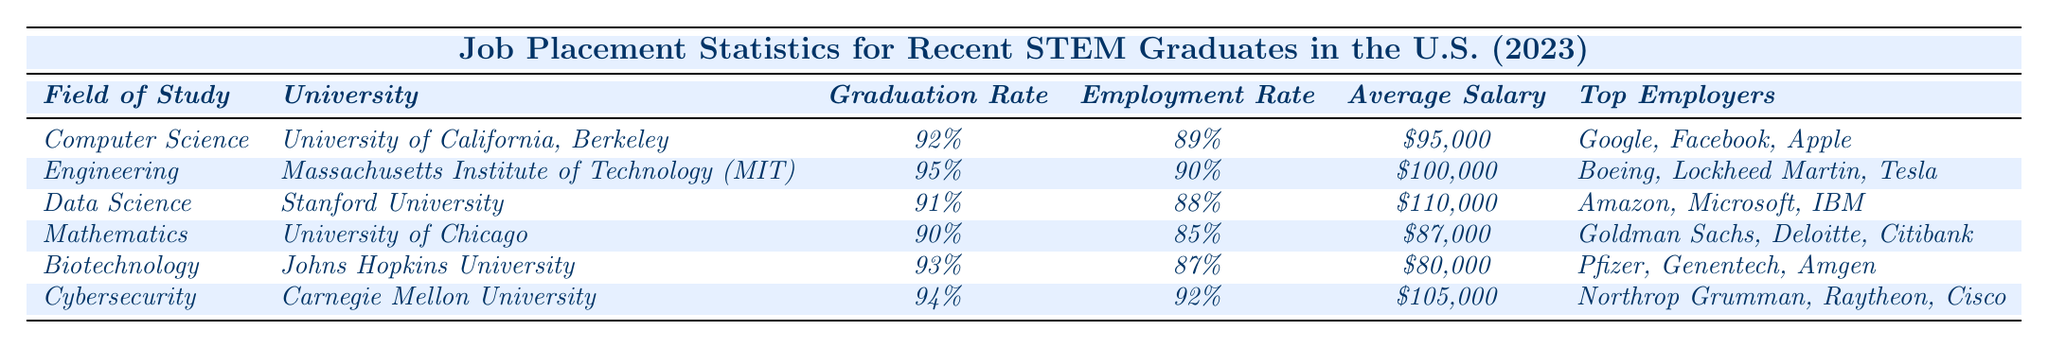What is the highest average salary among the fields of study listed? The average salaries for each field are $95,000 for Computer Science, $100,000 for Engineering, $110,000 for Data Science, $87,000 for Mathematics, $80,000 for Biotechnology, and $105,000 for Cybersecurity. The highest value is $110,000 for Data Science.
Answer: $110,000 Which university has the highest graduation rate? The graduation rates are 92% for Computer Science, 95% for Engineering, 91% for Data Science, 90% for Mathematics, 93% for Biotechnology, and 94% for Cybersecurity. The highest rate is 95% from MIT for Engineering.
Answer: 95% What percentage of graduates in Biotechnology found employment? The employment rate for Biotechnology graduates is 87%, as stated in the table.
Answer: 87% Is the average salary for graduates in Mathematics higher or lower than that for graduates in Computer Science? The average salary for Mathematics is $87,000, while for Computer Science it is $95,000. Since $87,000 is less than $95,000, it is lower.
Answer: Lower Which field of study has both the highest graduation rate and the highest employment rate? The graduation rates and employment rates show that Engineering has the highest graduation rate at 95% and an employment rate of 90%. No other field has both rates higher than these.
Answer: Engineering If you average the employment rates of all fields, what is the result? The employment rates are 89% (Computer Science), 90% (Engineering), 88% (Data Science), 85% (Mathematics), 87% (Biotechnology), and 92% (Cybersecurity). The sum is 89 + 90 + 88 + 85 + 87 + 92 = 531, then dividing by 6 gives an average of 88.5%.
Answer: 88.5% Are there any fields where the average salary exceeds $100,000? The average salaries are $95,000 for Computer Science, $100,000 for Engineering, $110,000 for Data Science, $87,000 for Mathematics, $80,000 for Biotechnology, and $105,000 for Cybersecurity. Data Science and Cybersecurity both exceed $100,000.
Answer: Yes What is the difference in employment rates between Data Science and Cybersecurity graduates? The employment rate for Data Science is 88% and for Cybersecurity is 92%. The difference is 92% - 88% = 4%.
Answer: 4% 